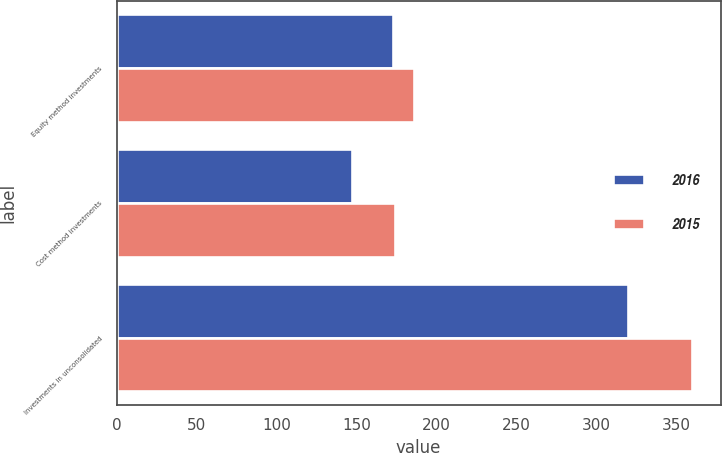<chart> <loc_0><loc_0><loc_500><loc_500><stacked_bar_chart><ecel><fcel>Equity method investments<fcel>Cost method investments<fcel>Investments in unconsolidated<nl><fcel>2016<fcel>173<fcel>147<fcel>320<nl><fcel>2015<fcel>186<fcel>174<fcel>360<nl></chart> 